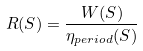<formula> <loc_0><loc_0><loc_500><loc_500>R ( S ) = \frac { W ( S ) } { \eta _ { p e r i o d } ( S ) }</formula> 